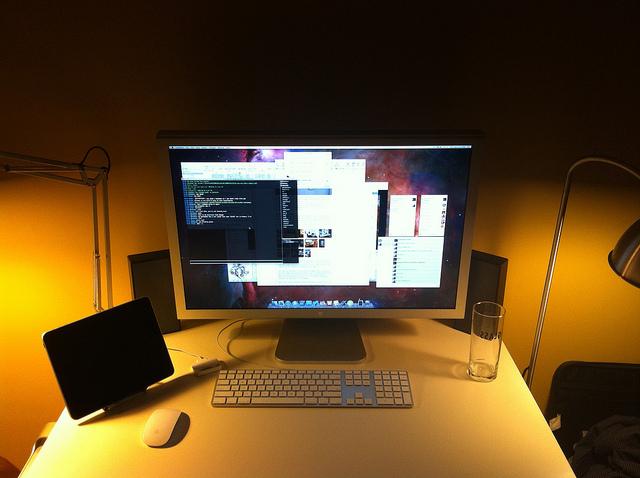Is the mouse wireless?
Short answer required. Yes. How many windows are open on the computer desktop?
Short answer required. 7. Is the glass on the desk full of grape juice?
Answer briefly. No. 